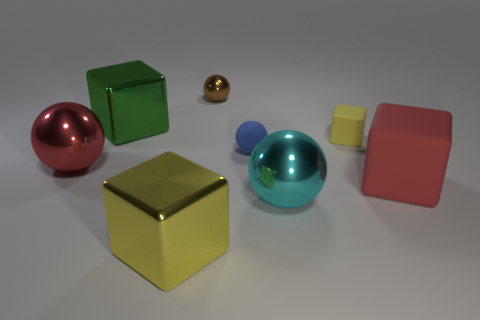Is the number of metallic blocks less than the number of small cyan matte spheres?
Give a very brief answer. No. There is a red block that is the same size as the red ball; what is its material?
Offer a very short reply. Rubber. Is the size of the metallic block in front of the green metallic thing the same as the red thing that is behind the red rubber thing?
Ensure brevity in your answer.  Yes. Is there a tiny thing made of the same material as the tiny yellow cube?
Offer a very short reply. Yes. How many things are red objects that are left of the brown metal sphere or big blocks?
Your answer should be very brief. 4. Is the material of the yellow object that is in front of the tiny blue matte object the same as the large green object?
Your response must be concise. Yes. Is the shape of the big rubber thing the same as the cyan shiny object?
Your answer should be very brief. No. There is a large metal sphere in front of the large rubber cube; what number of big green metal objects are behind it?
Provide a short and direct response. 1. What is the material of the red thing that is the same shape as the big green shiny object?
Ensure brevity in your answer.  Rubber. There is a sphere that is on the left side of the large yellow metallic cube; is it the same color as the big matte cube?
Ensure brevity in your answer.  Yes. 